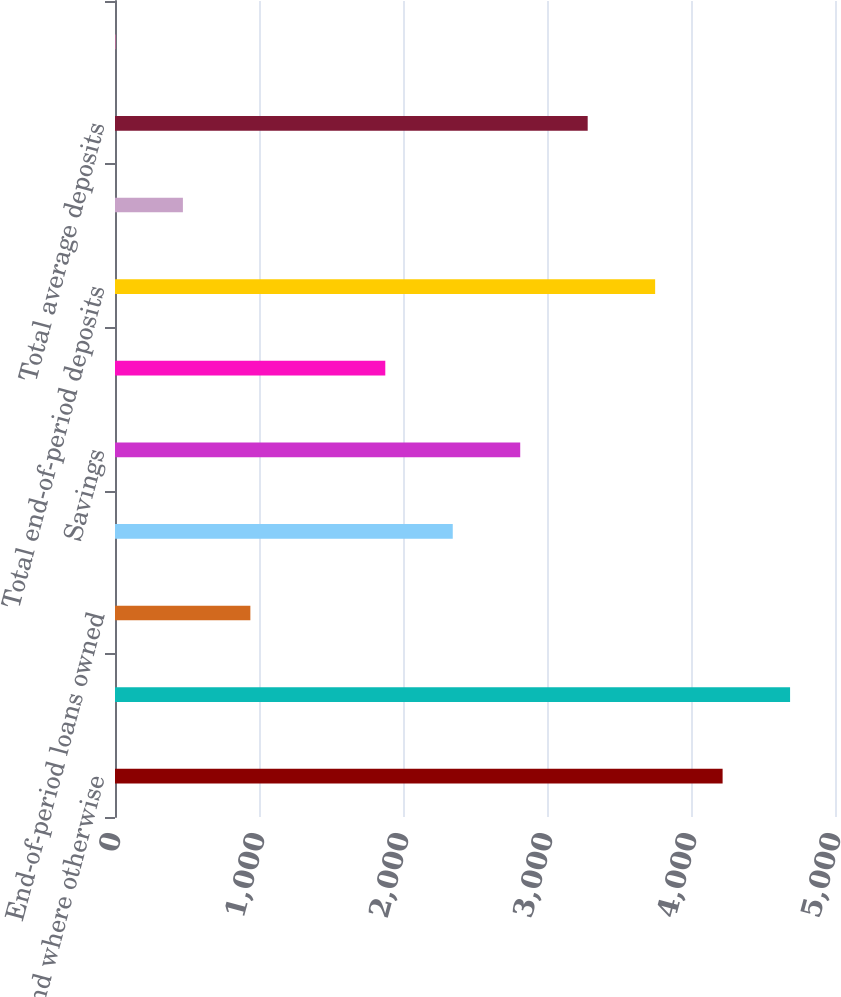Convert chart. <chart><loc_0><loc_0><loc_500><loc_500><bar_chart><fcel>ratios and where otherwise<fcel>Business banking origination<fcel>End-of-period loans owned<fcel>Checking<fcel>Savings<fcel>Time and other<fcel>Total end-of-period deposits<fcel>Average loans owned<fcel>Total average deposits<fcel>Deposit margin<nl><fcel>4219.53<fcel>4688.03<fcel>940.03<fcel>2345.53<fcel>2814.03<fcel>1877.03<fcel>3751.03<fcel>471.53<fcel>3282.53<fcel>3.03<nl></chart> 